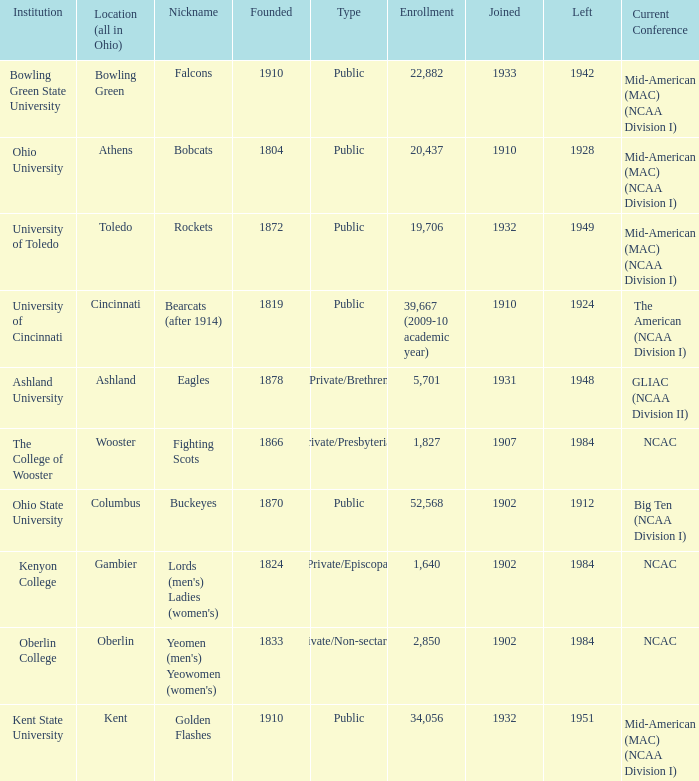Which founding year corresponds with the highest enrollment?  1910.0. 